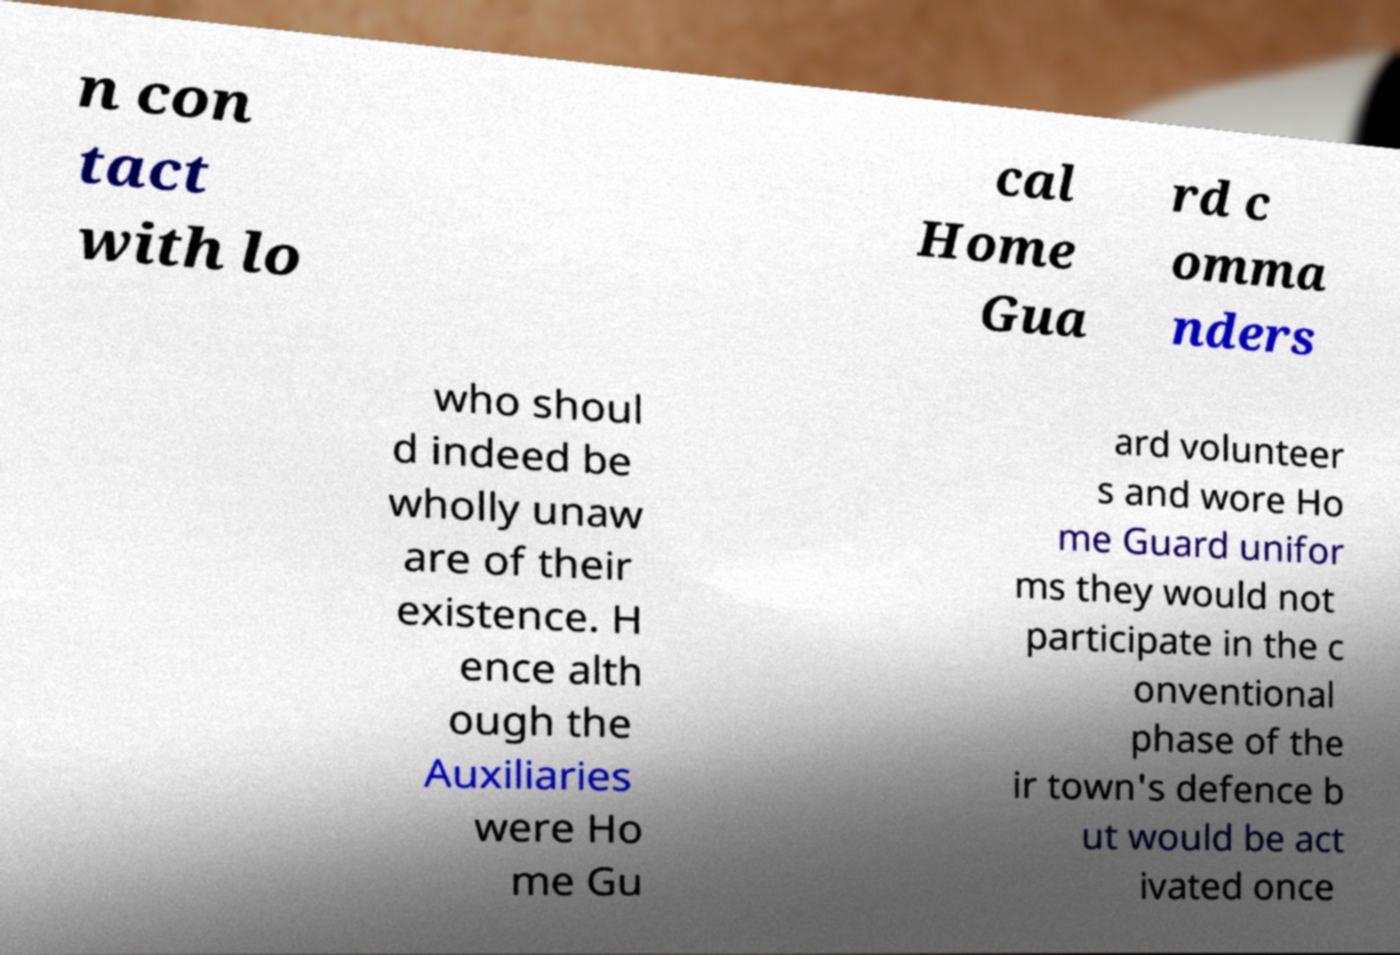What messages or text are displayed in this image? I need them in a readable, typed format. n con tact with lo cal Home Gua rd c omma nders who shoul d indeed be wholly unaw are of their existence. H ence alth ough the Auxiliaries were Ho me Gu ard volunteer s and wore Ho me Guard unifor ms they would not participate in the c onventional phase of the ir town's defence b ut would be act ivated once 